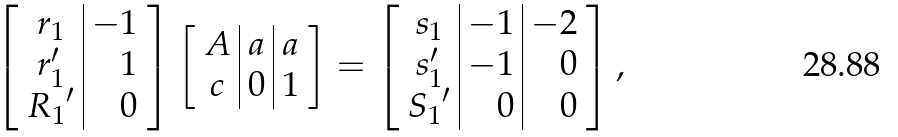Convert formula to latex. <formula><loc_0><loc_0><loc_500><loc_500>\left [ \begin{array} { c | r } r _ { 1 } & - 1 \\ r _ { 1 } ^ { \prime } & 1 \\ { R _ { 1 } } ^ { \prime } & 0 \end{array} \right ] \left [ \begin{array} { c | c | c } A & a & a \\ c & 0 & 1 \end{array} \right ] = \left [ \begin{array} { c | r | r } s _ { 1 } & - 1 & - 2 \\ s _ { 1 } ^ { \prime } & - 1 & 0 \\ { S _ { 1 } } ^ { \prime } & 0 & 0 \end{array} \right ] ,</formula> 